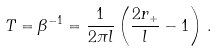Convert formula to latex. <formula><loc_0><loc_0><loc_500><loc_500>T = \beta ^ { - 1 } = \frac { 1 } { 2 \pi l } \left ( \frac { 2 r _ { + } } { l } - 1 \right ) \, .</formula> 